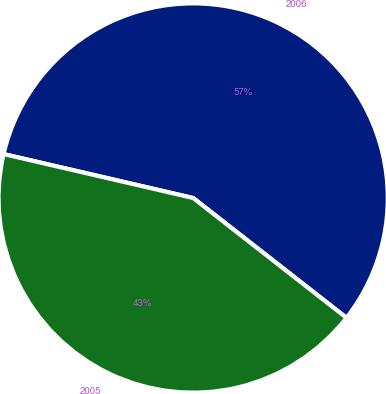Convert chart to OTSL. <chart><loc_0><loc_0><loc_500><loc_500><pie_chart><fcel>2006<fcel>2005<nl><fcel>56.93%<fcel>43.07%<nl></chart> 